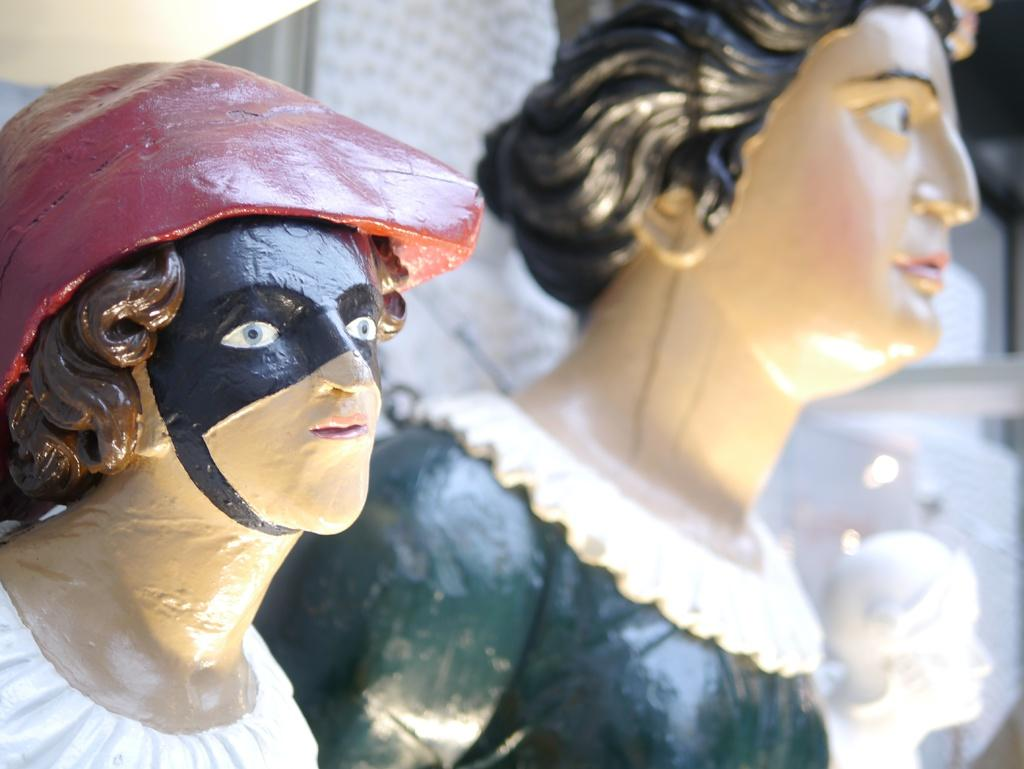What can be seen in the image? There are statues in the image. Can you describe the background of the image? The background of the image is blurred. What type of laborer is working in the background of the image? There is no laborer present in the image, as the background is blurred and does not show any people or activities. 